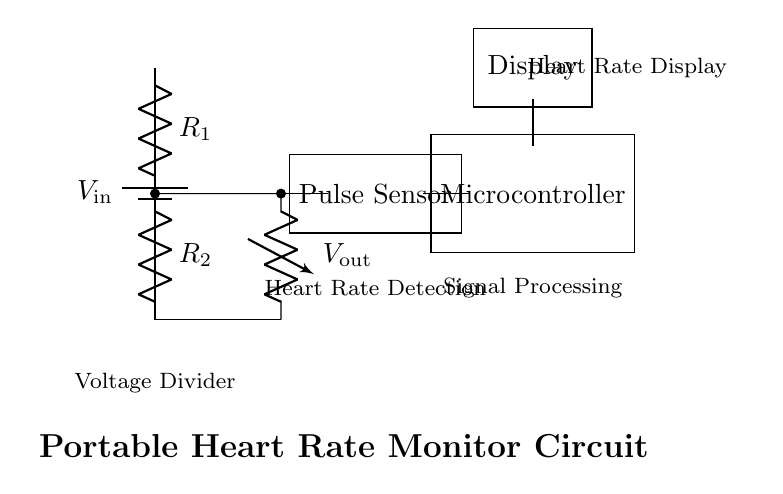What is the input voltage of the circuit? The input voltage is indicated as **V_in**, which is represented by the battery symbol in the circuit.
Answer: V_in What are the resistances in the voltage divider? The resistances are labeled **R_1** and **R_2** in the diagram, signifying their respective components in the voltage divider configuration.
Answer: R_1, R_2 What is the purpose of the voltage divider in this circuit? The voltage divider is used to reduce the input voltage to a level suitable for the pulse sensor, allowing it to measure the heart rate.
Answer: To reduce voltage What is the output voltage connected to? The output voltage labeled as **V_out** is connected to the pulse sensor, indicating that it provides the reduced voltage to the sensor for heart rate detection.
Answer: Pulse Sensor How does the microcontroller fit into the circuit? The microcontroller receives the signal from the pulse sensor, processes the heart rate data, and likely sends it to the display for viewing.
Answer: Signal processing Which component displays the heart rate? The component labeled "Display" is responsible for showing the heart rate to the user, indicating the final step in the circuit where the data becomes visible.
Answer: Display What role does the pulse sensor play in this circuit? The pulse sensor detects the heart rate and outputs a signal proportional to the rate, which is then processed by the microcontroller for further action.
Answer: Heart rate detection 